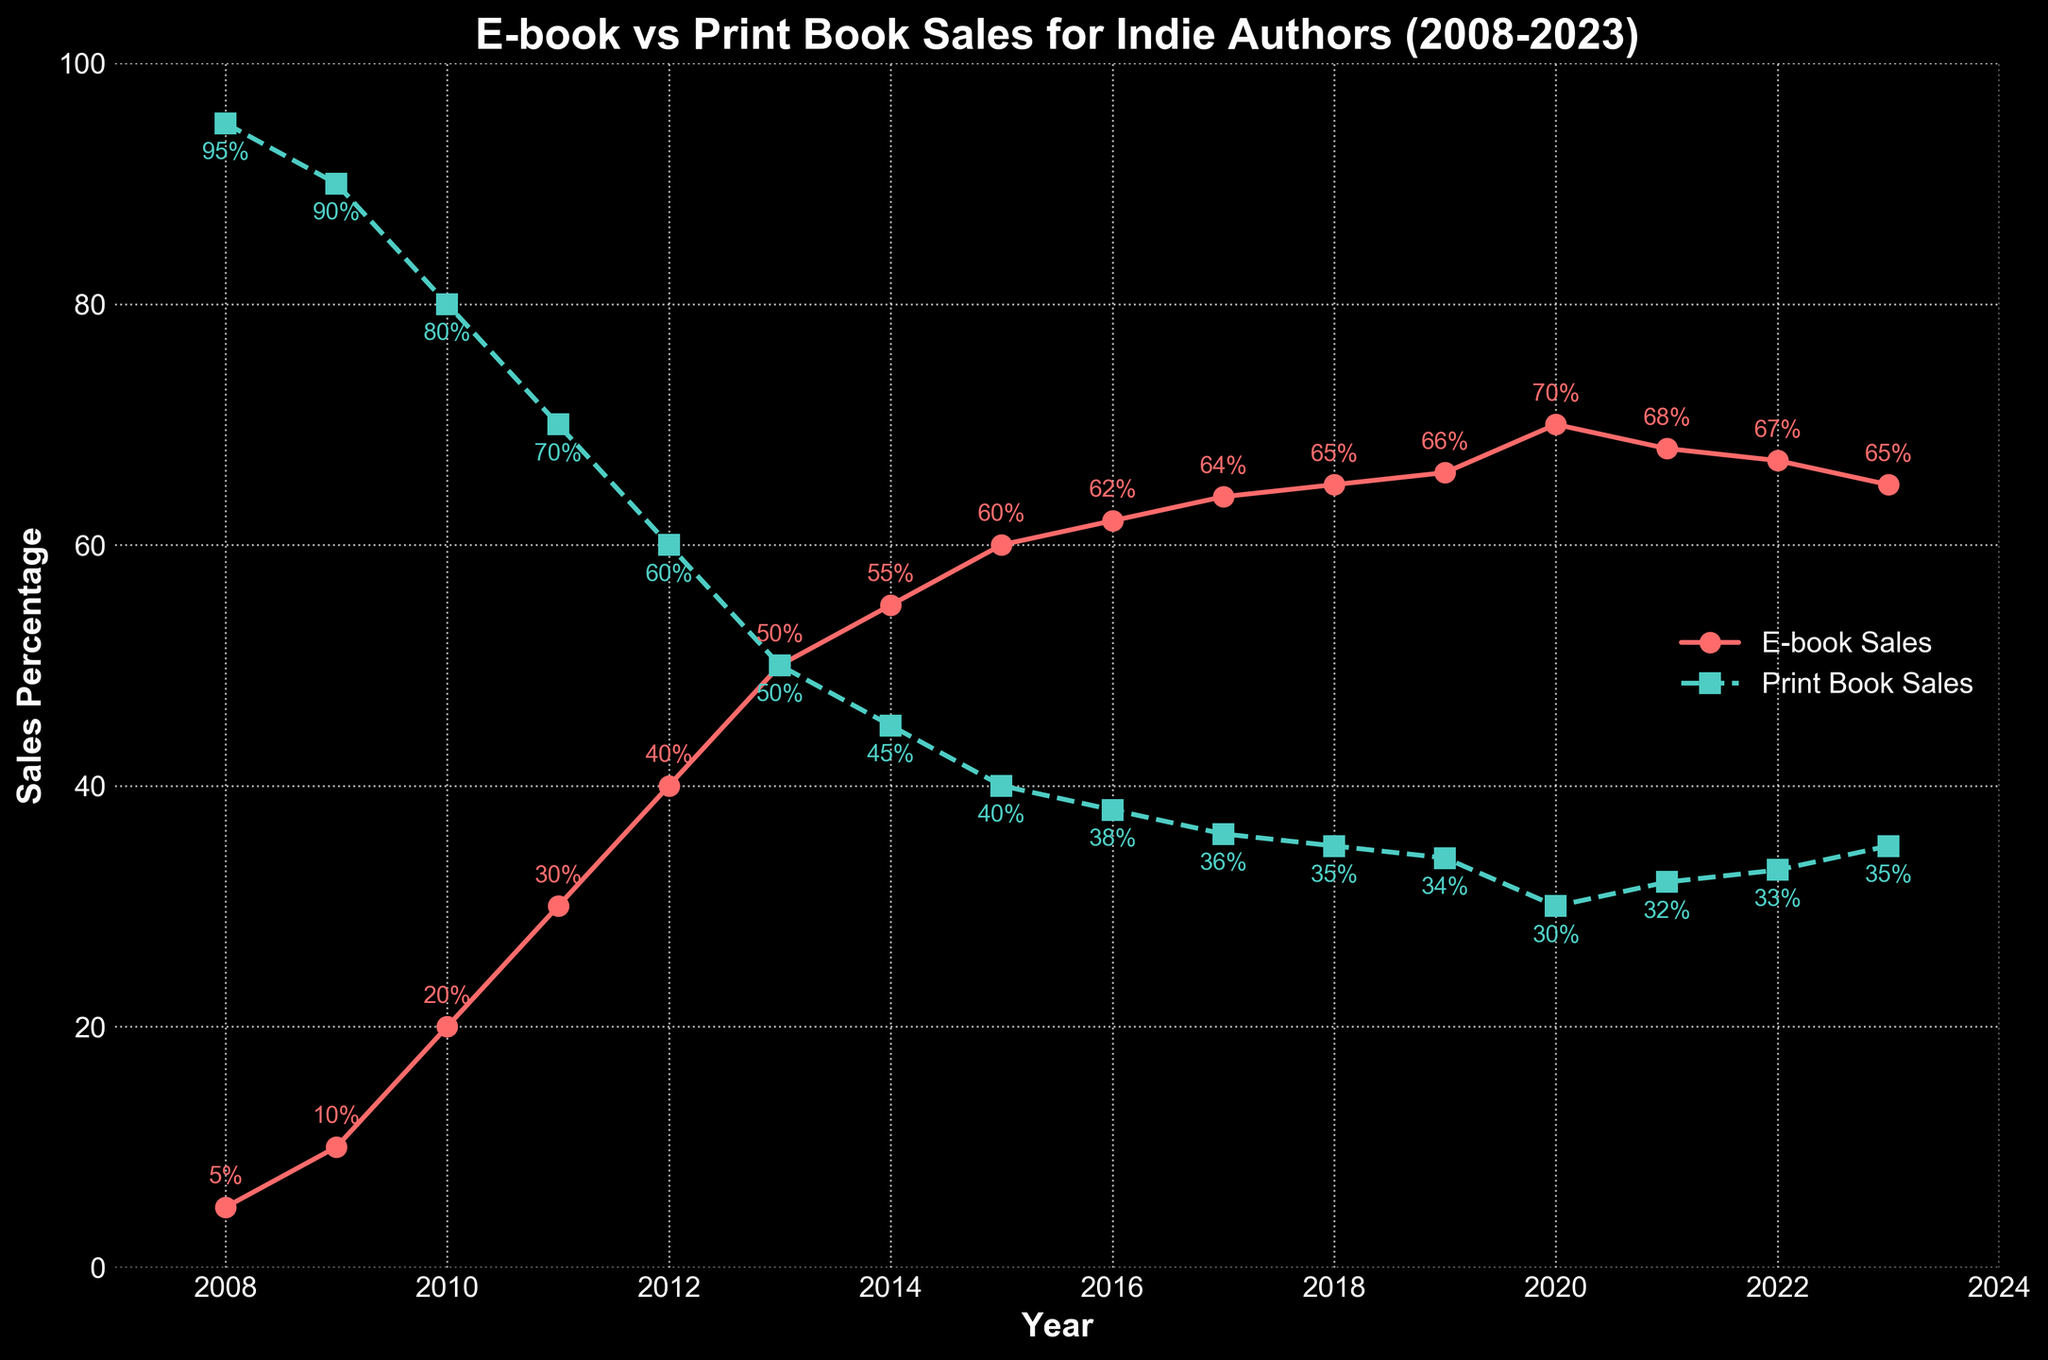What trend can be observed in the e-book sales percentage from 2008 to 2020? The e-book sales percentage shows a consistent increase from 5% in 2008 to a peak of 70% in 2020.
Answer: Consistent increase During which year did the e-book and print book sales percentages equal each other? According to the chart, the e-book and print book sales percentages are both 50% in the year 2013.
Answer: 2013 What is the approximate difference in e-book sales percentage between the years 2010 and 2017? In 2010, the e-book sales percentage is 20%, and in 2017, it is 64%. The difference is 64% - 20% = 44%.
Answer: 44% How do the print book sales percentages in 2015 and 2023 compare to each other? In 2015, the print book sales percentage is 40%, and in 2023, it is 35%. Therefore, the print book sales percentage in 2015 is higher than in 2023.
Answer: 2015 is higher What is the average e-book sales percentage over the 15-year period? To find the average, add up all the e-book sales percentages from 2008 to 2023 and divide by the number of years: (5 + 10 + 20 + 30 + 40 + 50 + 55 + 60 + 62 + 64 + 65 + 66 + 70 + 68 + 67 + 65) / 16 = 48.75%.
Answer: 48.75% How did the print book sales percentage change from 2013 to 2016? In 2013, the print book sales percentage was 50%, and in 2016, it dropped to 38%. The change is 50% - 38% = 12% decrease.
Answer: 12% decrease What was the peak percentage of e-book sales, and in which year did it occur? The peak percentage of e-book sales was 70%, occurring in the year 2020.
Answer: 70% in 2020 What visual feature marks the transition where e-book sales surpassed print book sales? The transition point where the red line (e-book sales) overtakes the green dashed line (print book sales) occurs between the years 2012 and 2013.
Answer: Between 2012 and 2013 In which year did print book sales see the biggest drop compared to the previous year? The biggest drop in print book sales compared to the previous year occurred between 2012 and 2013, where it decreased from 60% to 50%, a 10% drop.
Answer: 2013 How does the trend of e-book sales percentage from 2020 to 2023 differ from its trend from 2008 to 2020? From 2008 to 2020, the e-book sales percentage showed a steady increase each year. However, from 2020 to 2023, the e-book sales percentage slightly declined from 70% to 65%.
Answer: Initial increase, then slight decline 